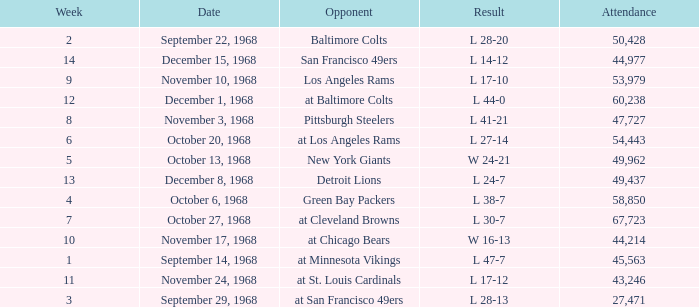Which Week has an Opponent of pittsburgh steelers, and an Attendance larger than 47,727? None. 